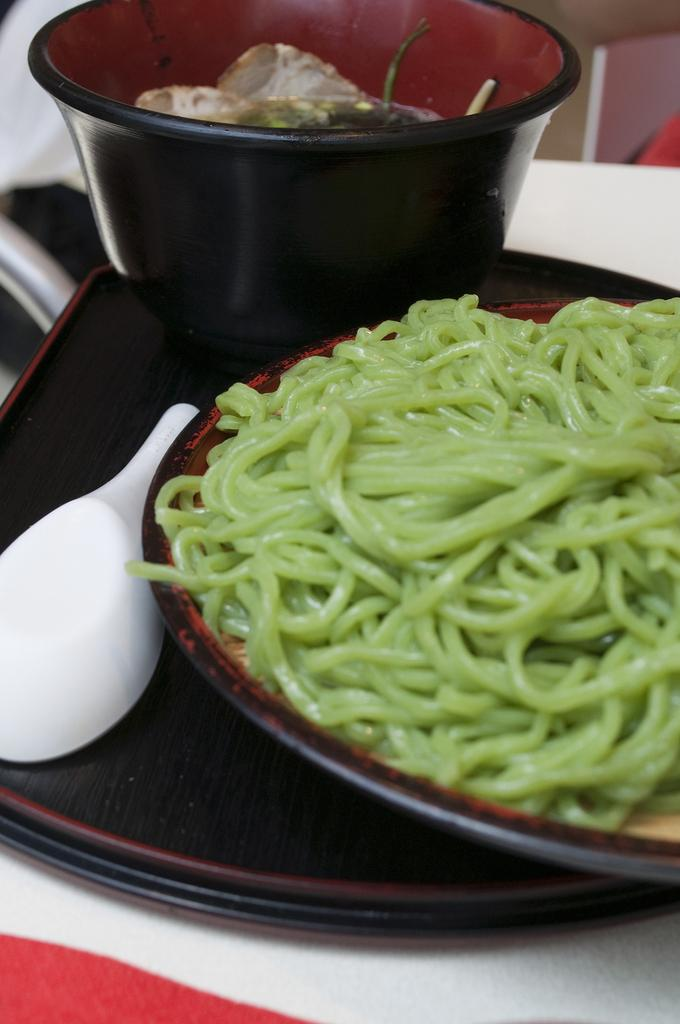What is on the plate that is visible in the image? There is a plate containing noodles in the image. What utensil is visible in the image? There is a spoon in the image. What other dish is present in the image besides the plate? There is a bowl in the image. What is the surface on which the plate, spoon, bowl, and tray are placed? The plate, spoon, bowl, and tray are placed on a table. What type of owl can be seen sitting on the beam in the image? There is no owl or beam present in the image. How does the presence of the noodles on the plate show respect in the image? The image does not convey any information about respect or cultural practices related to the noodles. 